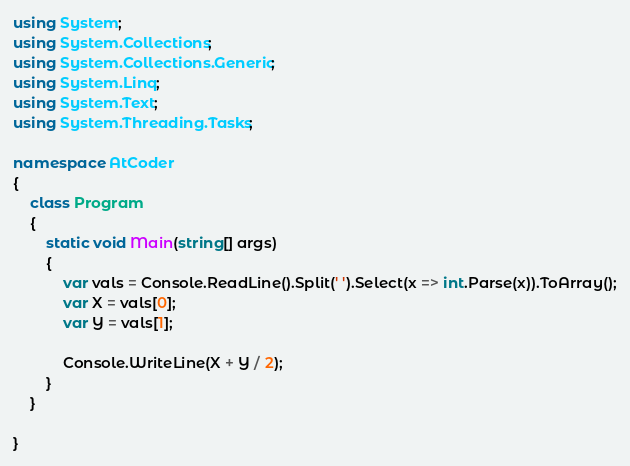Convert code to text. <code><loc_0><loc_0><loc_500><loc_500><_C#_>using System;
using System.Collections;
using System.Collections.Generic;
using System.Linq;
using System.Text;
using System.Threading.Tasks;

namespace AtCoder
{
    class Program
    {
        static void Main(string[] args)
        {
            var vals = Console.ReadLine().Split(' ').Select(x => int.Parse(x)).ToArray();
            var X = vals[0];
            var Y = vals[1];

            Console.WriteLine(X + Y / 2);
        }
    }

}
</code> 